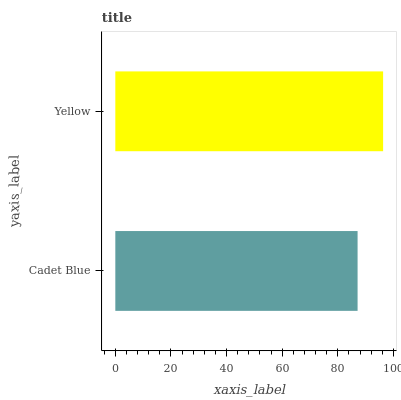Is Cadet Blue the minimum?
Answer yes or no. Yes. Is Yellow the maximum?
Answer yes or no. Yes. Is Yellow the minimum?
Answer yes or no. No. Is Yellow greater than Cadet Blue?
Answer yes or no. Yes. Is Cadet Blue less than Yellow?
Answer yes or no. Yes. Is Cadet Blue greater than Yellow?
Answer yes or no. No. Is Yellow less than Cadet Blue?
Answer yes or no. No. Is Yellow the high median?
Answer yes or no. Yes. Is Cadet Blue the low median?
Answer yes or no. Yes. Is Cadet Blue the high median?
Answer yes or no. No. Is Yellow the low median?
Answer yes or no. No. 